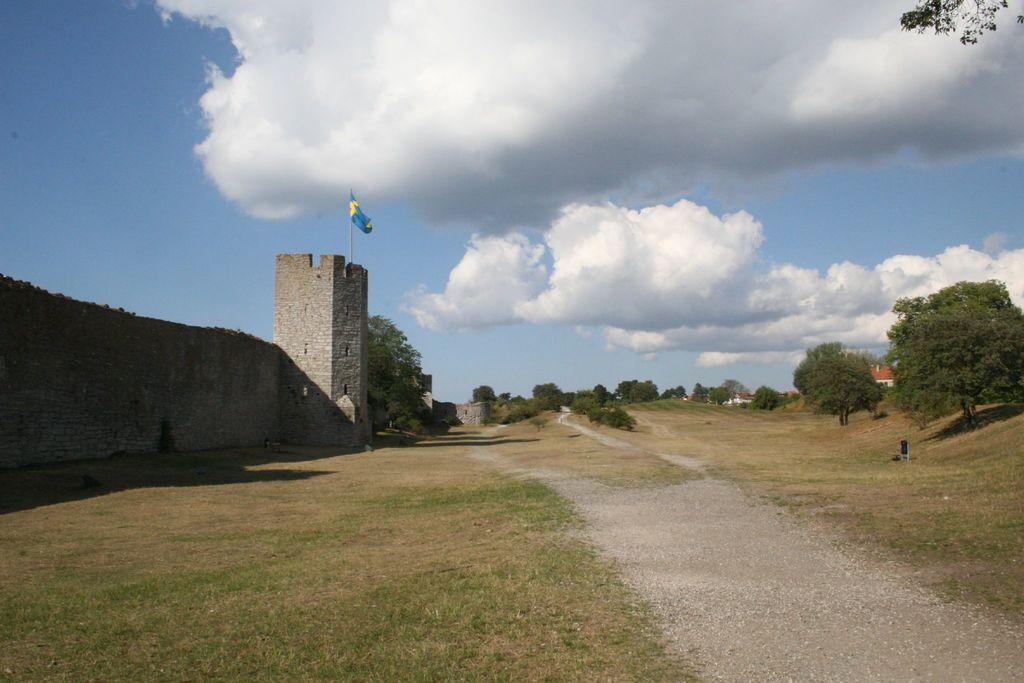Describe this image in one or two sentences. In this image I can see an open grass ground and on it I can see number of trees. On the both sides of the image I can see few buildings and on the left side of the image I can see a flag on the building. On the top side of the image I can see clouds and the sky. On the top right side of the image I can see leaves of a tree and I can also see shadows on the ground. 